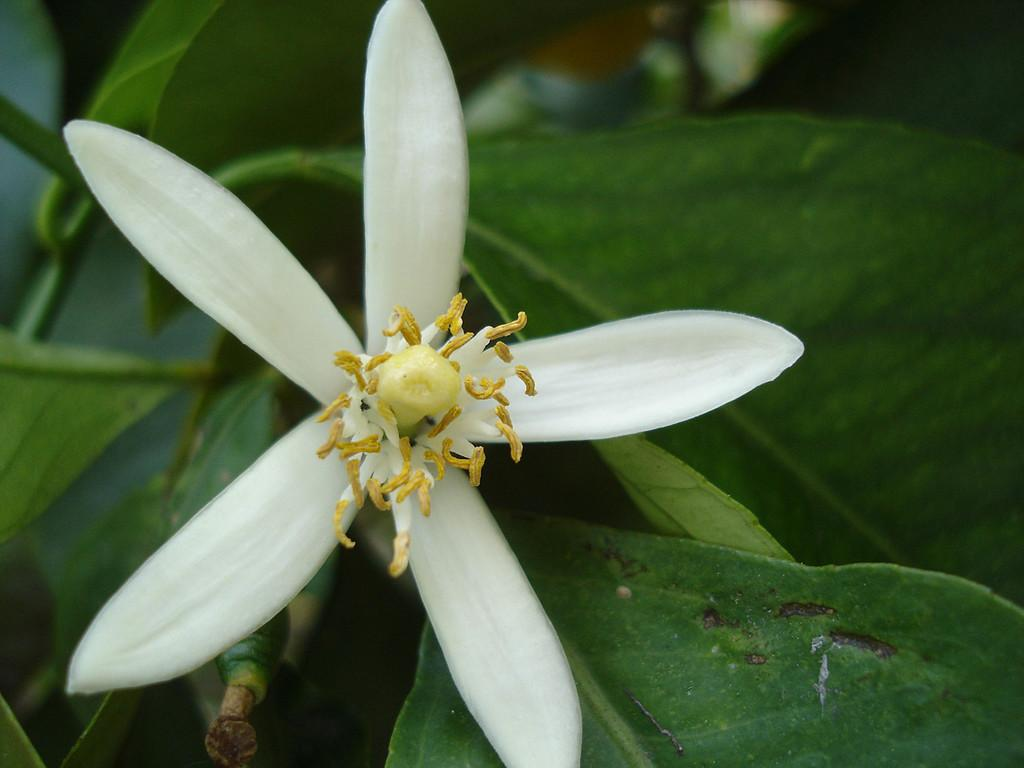What type of flower is in the picture? There is a white color flower in the picture. What else can be seen in the picture besides the flower? There are leaves in the picture. What type of lace is used to decorate the yak in the picture? There is no yak or lace present in the picture; it features a white color flower and leaves. 